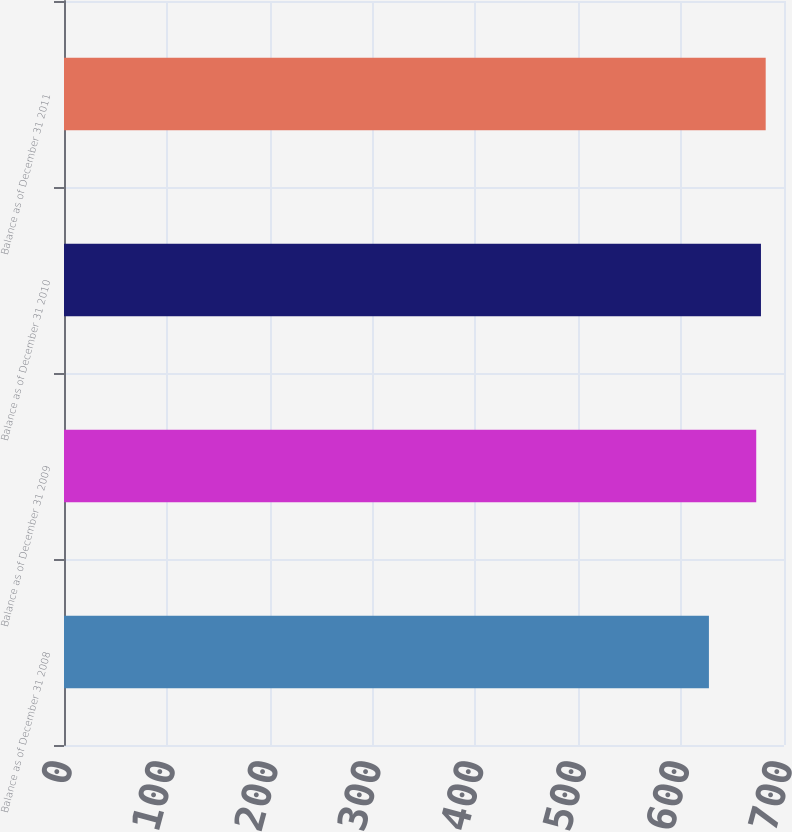Convert chart. <chart><loc_0><loc_0><loc_500><loc_500><bar_chart><fcel>Balance as of December 31 2008<fcel>Balance as of December 31 2009<fcel>Balance as of December 31 2010<fcel>Balance as of December 31 2011<nl><fcel>627<fcel>673<fcel>677.6<fcel>682.2<nl></chart> 